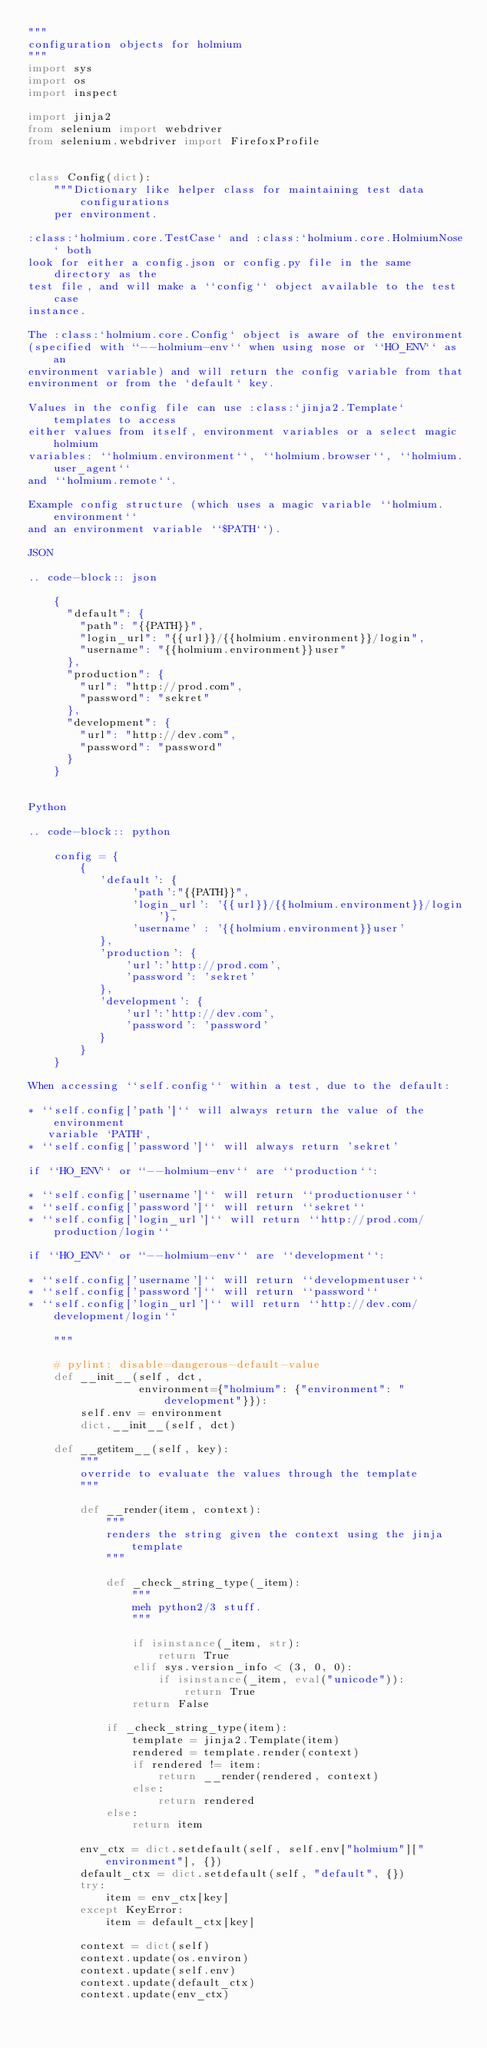Convert code to text. <code><loc_0><loc_0><loc_500><loc_500><_Python_>"""
configuration objects for holmium
"""
import sys
import os
import inspect

import jinja2
from selenium import webdriver
from selenium.webdriver import FirefoxProfile


class Config(dict):
    """Dictionary like helper class for maintaining test data configurations
    per environment.

:class:`holmium.core.TestCase` and :class:`holmium.core.HolmiumNose` both
look for either a config.json or config.py file in the same directory as the
test file, and will make a ``config`` object available to the test case
instance.

The :class:`holmium.core.Config` object is aware of the environment
(specified with ``--holmium-env`` when using nose or ``HO_ENV`` as an
environment variable) and will return the config variable from that
environment or from the `default` key.

Values in the config file can use :class:`jinja2.Template` templates to access
either values from itself, environment variables or a select magic holmium
variables: ``holmium.environment``, ``holmium.browser``, ``holmium.user_agent``
and ``holmium.remote``.

Example config structure (which uses a magic variable ``holmium.environment``
and an environment variable ``$PATH``).

JSON

.. code-block:: json

    {
      "default": {
        "path": "{{PATH}}",
        "login_url": "{{url}}/{{holmium.environment}}/login",
        "username": "{{holmium.environment}}user"
      },
      "production": {
        "url": "http://prod.com",
        "password": "sekret"
      },
      "development": {
        "url": "http://dev.com",
        "password": "password"
      }
    }


Python

.. code-block:: python

    config = {
        {
           'default': {
                'path':"{{PATH}}",
                'login_url': '{{url}}/{{holmium.environment}}/login'},
                'username' : '{{holmium.environment}}user'
           },
           'production': {
               'url':'http://prod.com',
               'password': 'sekret'
           },
           'development': {
               'url':'http://dev.com',
               'password': 'password'
           }
        }
    }

When accessing ``self.config`` within a test, due to the default:

* ``self.config['path']`` will always return the value of the environment
   variable `PATH`,
* ``self.config['password']`` will always return 'sekret'

if ``HO_ENV`` or ``--holmium-env`` are ``production``:

* ``self.config['username']`` will return ``productionuser``
* ``self.config['password']`` will return ``sekret``
* ``self.config['login_url']`` will return ``http://prod.com/production/login``

if ``HO_ENV`` or ``--holmium-env`` are ``development``:

* ``self.config['username']`` will return ``developmentuser``
* ``self.config['password']`` will return ``password``
* ``self.config['login_url']`` will return ``http://dev.com/development/login``

    """

    # pylint: disable=dangerous-default-value
    def __init__(self, dct,
                 environment={"holmium": {"environment": "development"}}):
        self.env = environment
        dict.__init__(self, dct)

    def __getitem__(self, key):
        """
        override to evaluate the values through the template
        """

        def __render(item, context):
            """
            renders the string given the context using the jinja template
            """

            def _check_string_type(_item):
                """
                meh python2/3 stuff.
                """

                if isinstance(_item, str):
                    return True
                elif sys.version_info < (3, 0, 0):
                    if isinstance(_item, eval("unicode")):
                        return True
                return False

            if _check_string_type(item):
                template = jinja2.Template(item)
                rendered = template.render(context)
                if rendered != item:
                    return __render(rendered, context)
                else:
                    return rendered
            else:
                return item

        env_ctx = dict.setdefault(self, self.env["holmium"]["environment"], {})
        default_ctx = dict.setdefault(self, "default", {})
        try:
            item = env_ctx[key]
        except KeyError:
            item = default_ctx[key]

        context = dict(self)
        context.update(os.environ)
        context.update(self.env)
        context.update(default_ctx)
        context.update(env_ctx)</code> 